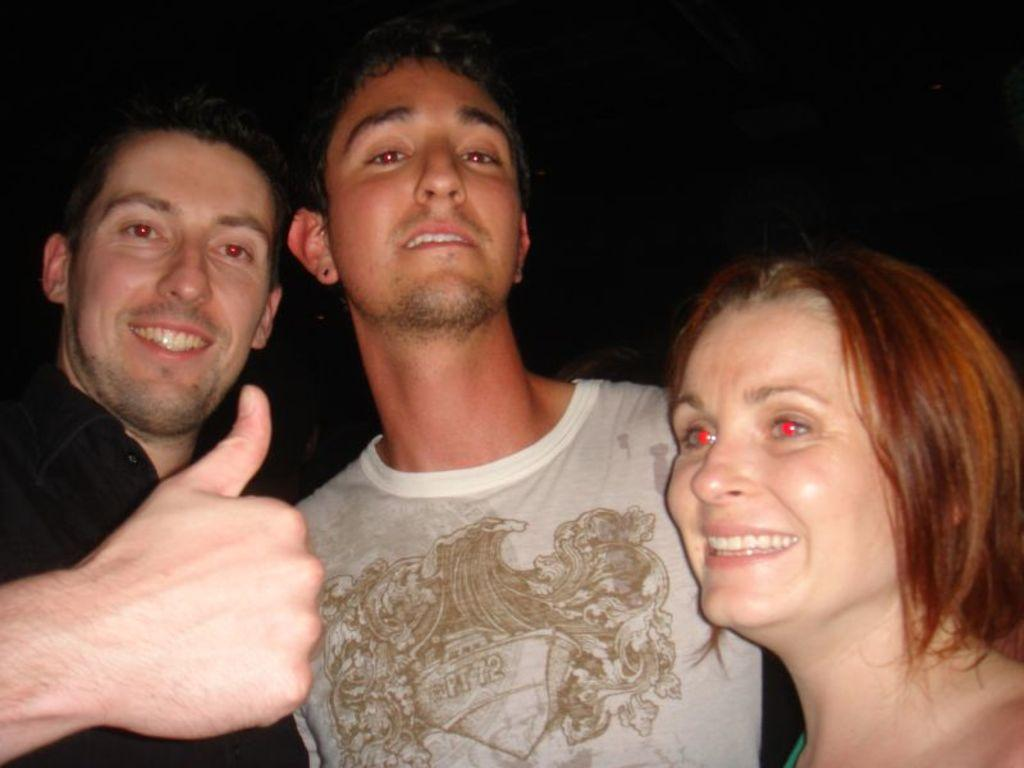Where was the image likely taken? The image was likely taken outside, based on the provided facts. How many people are in the foreground of the image? There are three persons in the foreground of the image. What is the facial expression of the persons in the image? The persons are smiling in the image. What surface are the persons standing on? The persons are standing on the ground in the image. How would you describe the lighting in the background of the image? The background of the image is very dark. What type of toys can be seen in the hands of the persons in the image? There are no toys visible in the hands of the persons in the image. Is this a family gathering, and who are the family members? The provided facts do not mention anything about a family gathering or the relationships between the persons in the image. 